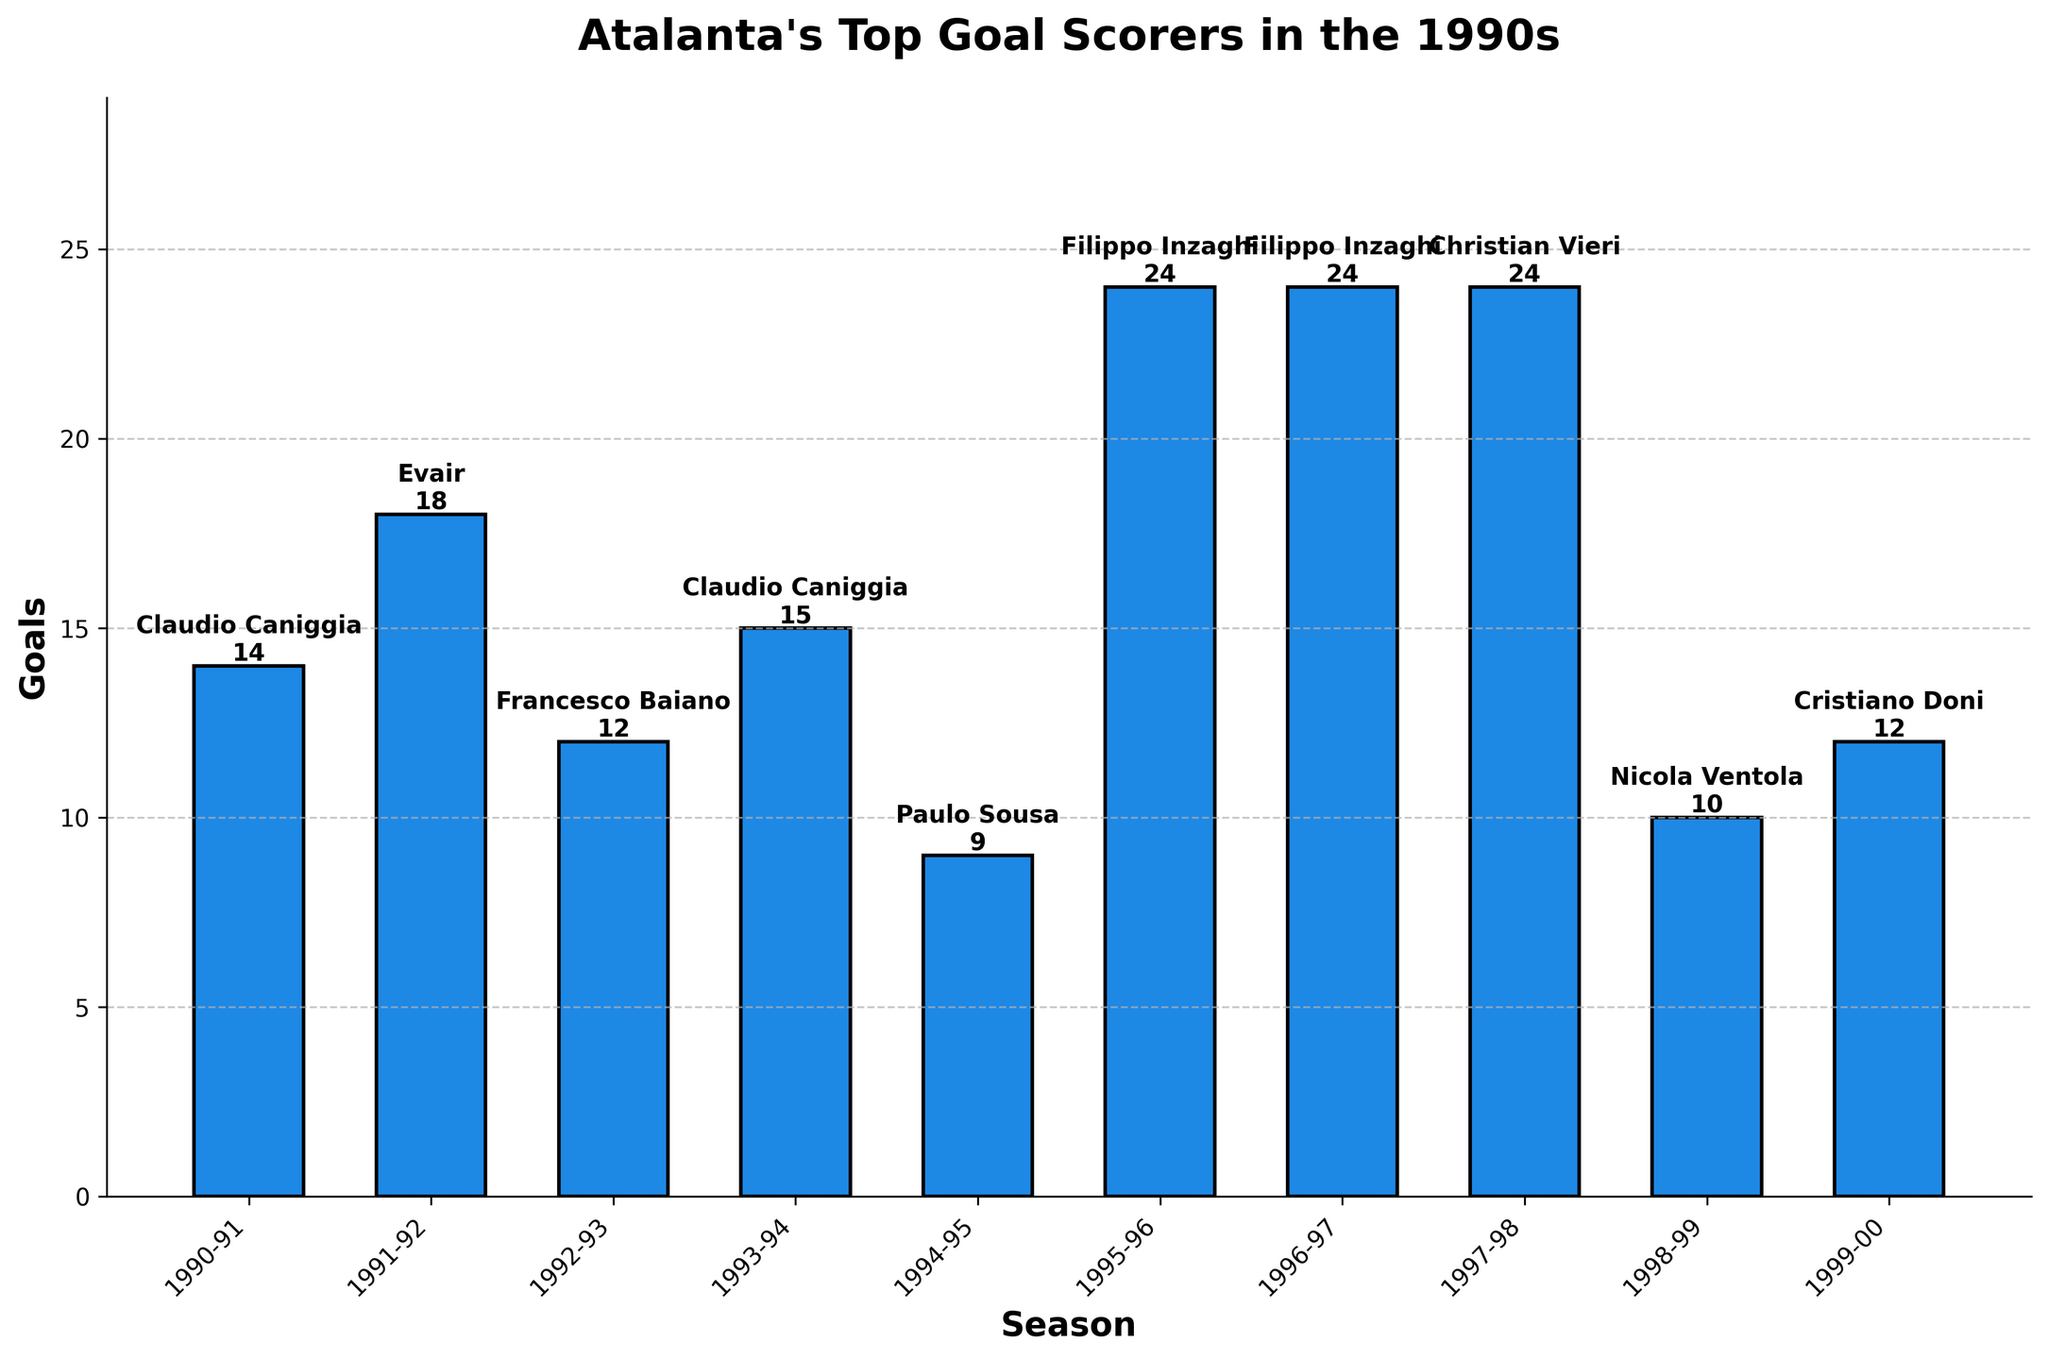who scored the most goals in the 1990s? The bar representing "Filippo Inzaghi" in the 1995-96, 1996-97, and "Christian Vieri" in the 1997-98 seasons are the tallest and all have 24 goals, indicating they scored the most goals.
Answer: Filippo Inzaghi and Christian Vieri who was Atalanta's top goal scorer in the 1998-99 season? The bar for the 1998-99 season shows "Nicola Ventola" with 10 goals.
Answer: Nicola Ventola which season did Cristiano Doni appear as the top goal scorer and how many goals did he score? The bar for the 1999-00 season shows "Cristiano Doni" with 12 goals.
Answer: 1999-00, 12 goals how many seasons did Claudio Caniggia appear as the top goal scorer, and what were his total goals across these seasons? Claudio Caniggia appears as the top goal scorer in the 1990-91 and 1993-94 seasons. He scored 14 goals in the 1990-91 season and 15 goals in the 1993-94 season. Adding these together, 14 + 15 = 29 goals.
Answer: 2 seasons, 29 goals who scored more goals, Evair in the 1991-92 season or Francesco Baiano in the 1992-93 season? Comparing the bars, Evair in 1991-92 scored 18 goals while Francesco Baiano in 1992-93 scored 12 goals.
Answer: Evair what is the average number of goals scored by the top goal scorers over the nine seasons? Sum all goals: 14+18+12+15+9+24+24+24+10+12 = 162. There are 10 seasons, so the average number of goals is 162 / 10 = 16.2
Answer: 16.2 during which seasons did the top goal scorer score at least 20 goals? The bars for the 1995-96, 1996-97, and 1997-98 seasons show 24 goals each.
Answer: 1995-96, 1996-97, 1997-98 who was the top goal scorer for two consecutive seasons during the 1990s and how many goals did they score each season? Filippo Inzaghi was the top goal scorer for two consecutive seasons: 1995-96 and 1996-97, scoring 24 goals each season.
Answer: Filippo Inzaghi, 24 goals each which season had the lowest number of goals by the top scorer, and who was the player? The bar for the 1994-95 season is the shortest, with 9 goals by Paulo Sousa.
Answer: 1994-95, Paulo Sousa 